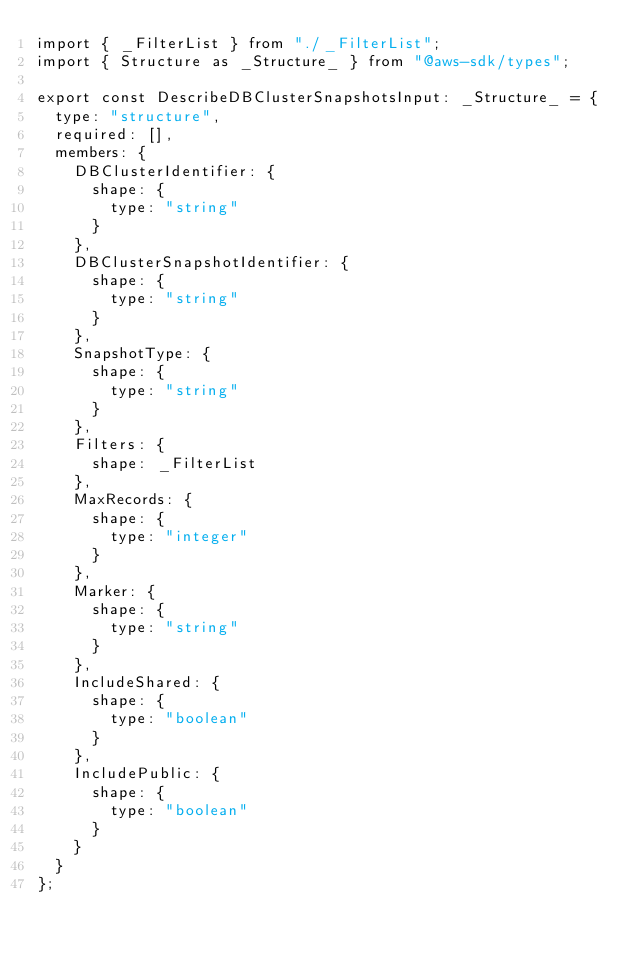<code> <loc_0><loc_0><loc_500><loc_500><_TypeScript_>import { _FilterList } from "./_FilterList";
import { Structure as _Structure_ } from "@aws-sdk/types";

export const DescribeDBClusterSnapshotsInput: _Structure_ = {
  type: "structure",
  required: [],
  members: {
    DBClusterIdentifier: {
      shape: {
        type: "string"
      }
    },
    DBClusterSnapshotIdentifier: {
      shape: {
        type: "string"
      }
    },
    SnapshotType: {
      shape: {
        type: "string"
      }
    },
    Filters: {
      shape: _FilterList
    },
    MaxRecords: {
      shape: {
        type: "integer"
      }
    },
    Marker: {
      shape: {
        type: "string"
      }
    },
    IncludeShared: {
      shape: {
        type: "boolean"
      }
    },
    IncludePublic: {
      shape: {
        type: "boolean"
      }
    }
  }
};
</code> 